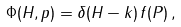Convert formula to latex. <formula><loc_0><loc_0><loc_500><loc_500>\Phi ( H , p ) = \delta ( H - k ) \, f ( P ) \, ,</formula> 